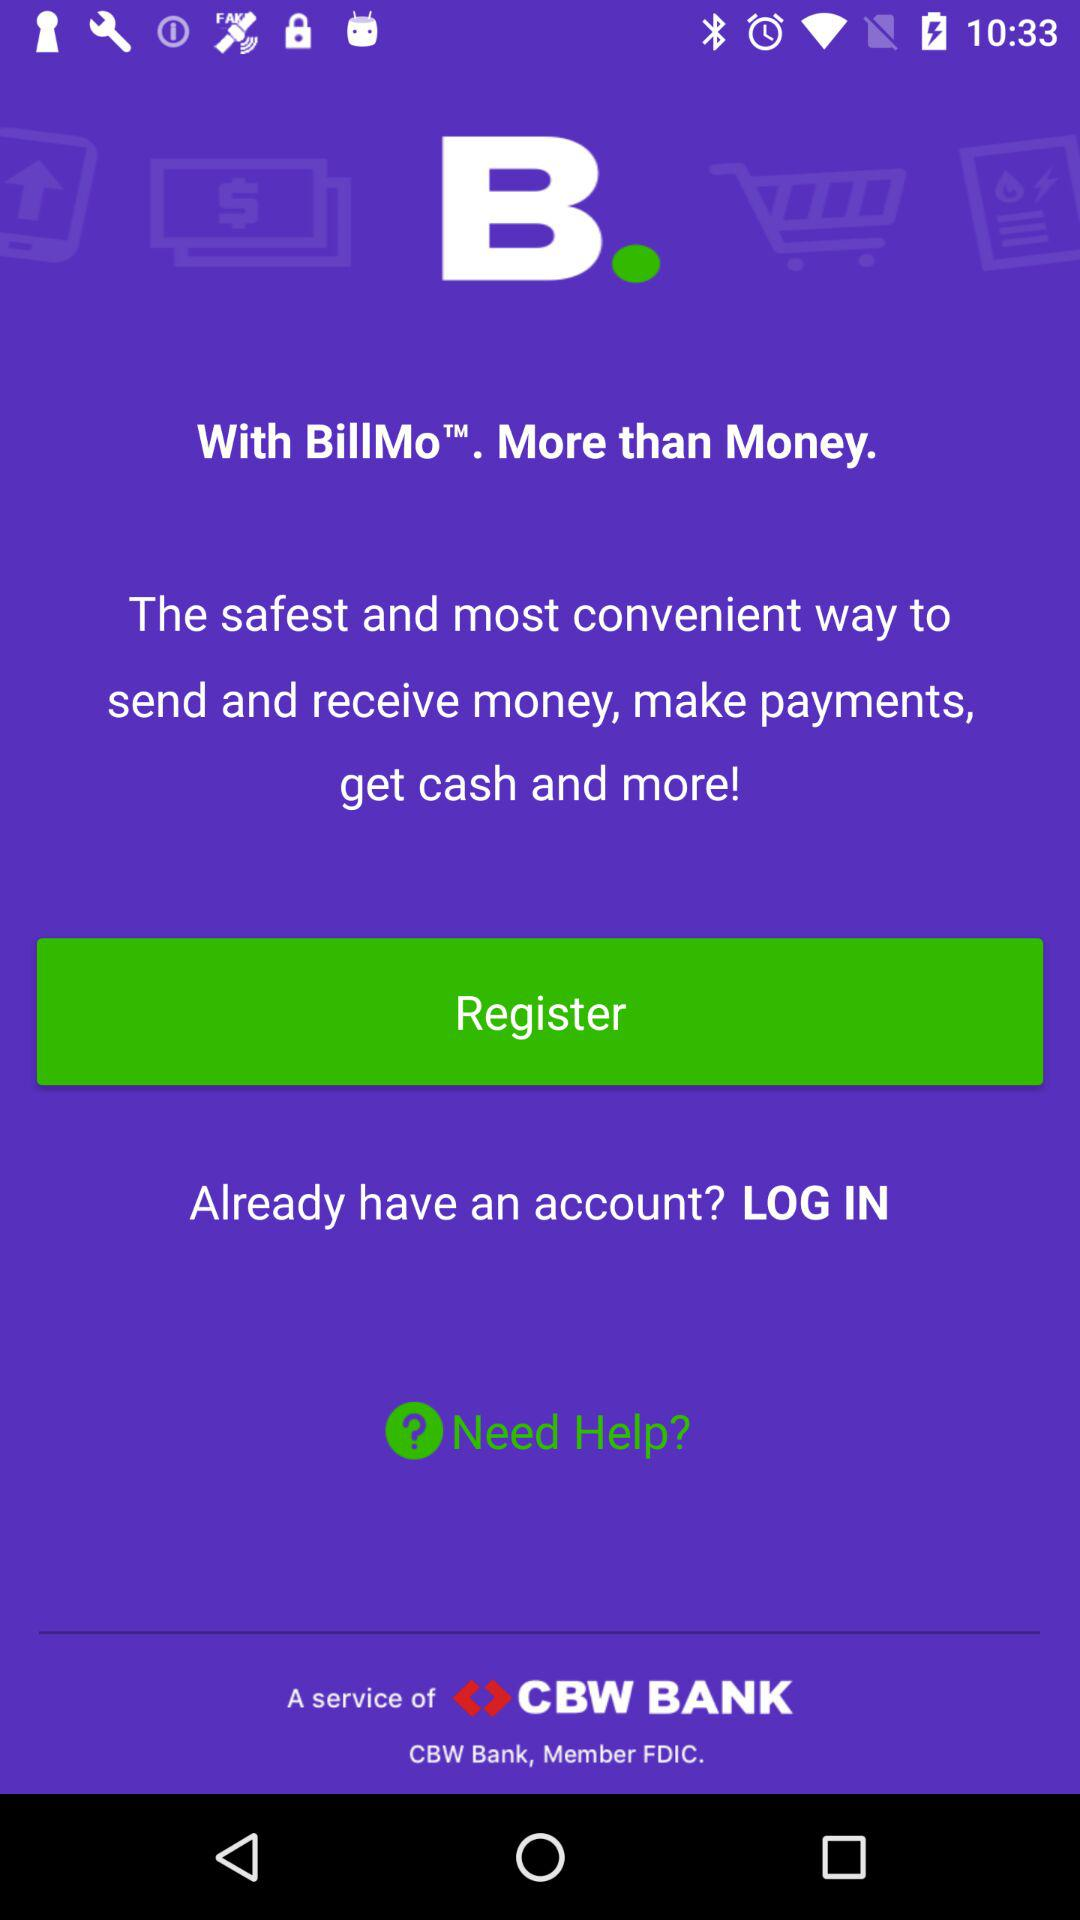What is the application name? The application name is "BillMo". 